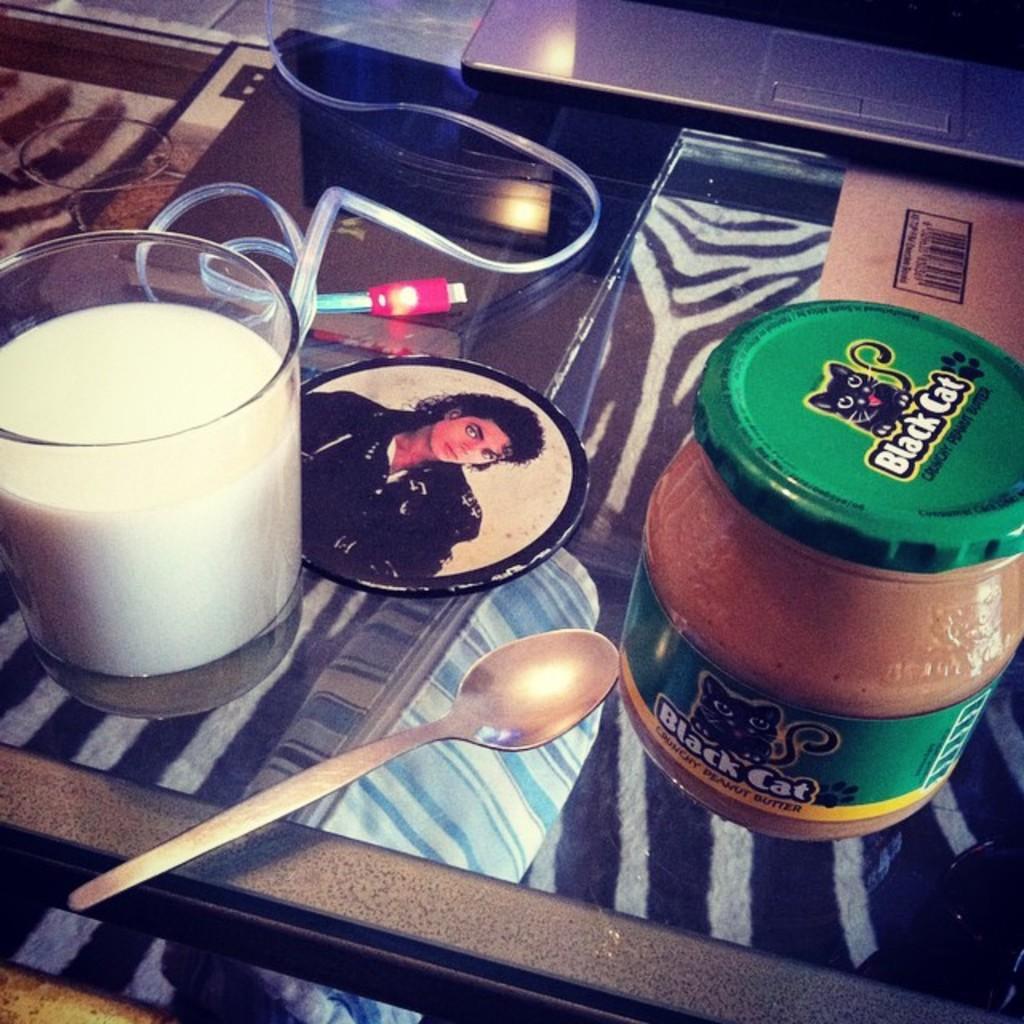How would you summarize this image in a sentence or two? In the image we can see there is table on which there is glass of milk, spoon and glass of butter. 